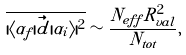<formula> <loc_0><loc_0><loc_500><loc_500>\overline { | \langle \alpha _ { f } | \vec { d } | \alpha _ { i } \rangle | ^ { 2 } } \sim \frac { N _ { e f f } R _ { v a l } ^ { 2 } } { N _ { t o t } } ,</formula> 